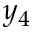Convert formula to latex. <formula><loc_0><loc_0><loc_500><loc_500>y _ { 4 }</formula> 